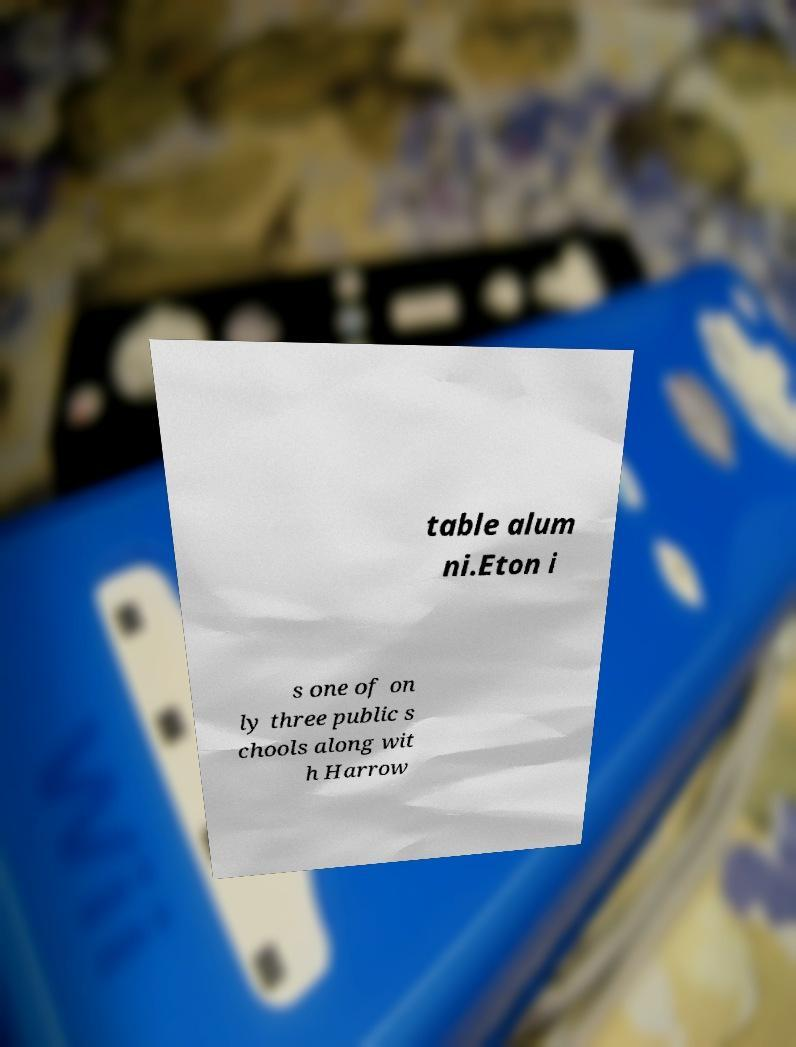Could you assist in decoding the text presented in this image and type it out clearly? table alum ni.Eton i s one of on ly three public s chools along wit h Harrow 